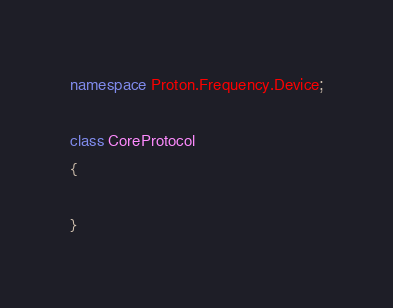Convert code to text. <code><loc_0><loc_0><loc_500><loc_500><_C#_>namespace Proton.Frequency.Device;

class CoreProtocol
{

}
</code> 